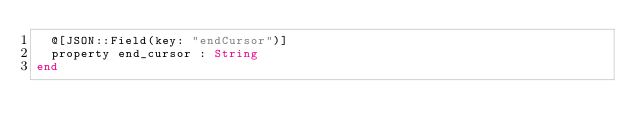<code> <loc_0><loc_0><loc_500><loc_500><_Crystal_>  @[JSON::Field(key: "endCursor")]
  property end_cursor : String
end
</code> 